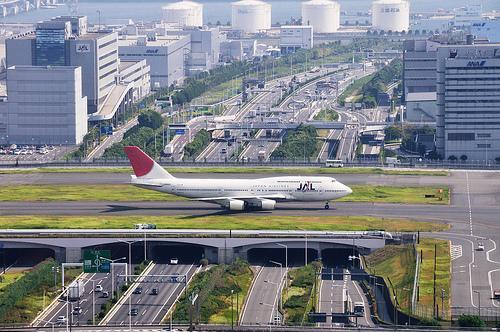How many airplanes are visible?
Give a very brief answer. 1. 